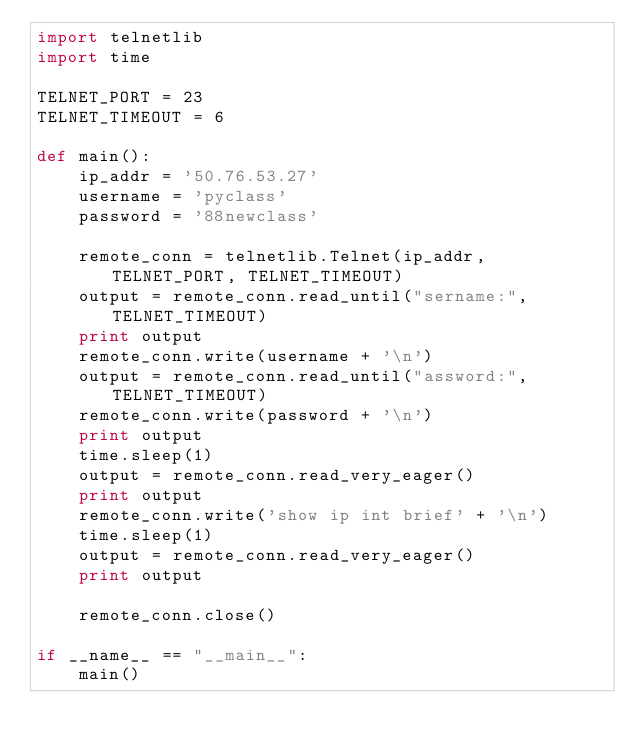Convert code to text. <code><loc_0><loc_0><loc_500><loc_500><_Python_>import telnetlib
import time

TELNET_PORT = 23
TELNET_TIMEOUT = 6

def main():
    ip_addr = '50.76.53.27'
    username = 'pyclass'
    password = '88newclass'

    remote_conn = telnetlib.Telnet(ip_addr, TELNET_PORT, TELNET_TIMEOUT)
    output = remote_conn.read_until("sername:", TELNET_TIMEOUT)
    print output
    remote_conn.write(username + '\n')
    output = remote_conn.read_until("assword:", TELNET_TIMEOUT)
    remote_conn.write(password + '\n')
    print output
    time.sleep(1)
    output = remote_conn.read_very_eager()
    print output
    remote_conn.write('show ip int brief' + '\n')
    time.sleep(1)
    output = remote_conn.read_very_eager()
    print output

    remote_conn.close()
    
if __name__ == "__main__":
    main()
</code> 